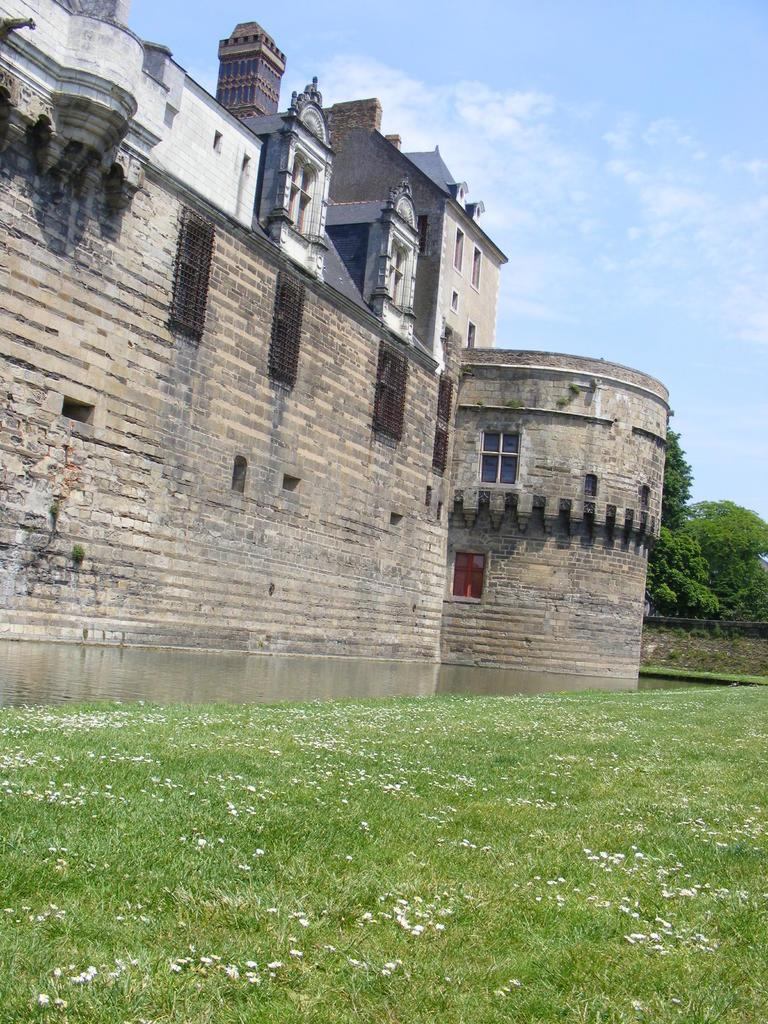What type of structure is visible in the image? There is a building with windows in the image. What is on the ground in the image? There is grass on the ground in the image. What type of plants can be seen in the image? There are flowers and trees in the image. What is visible in the background of the image? There are trees in the background of the image. What is visible at the top of the image? The sky is visible in the image, and there are clouds in the sky. What type of wax is being used to create the clouds in the image? There is no wax present in the image; the clouds are natural formations in the sky. What type of pie is being served on the grass in the image? There is no pie present in the image; the image only shows a building, grass, flowers, trees, and the sky. 